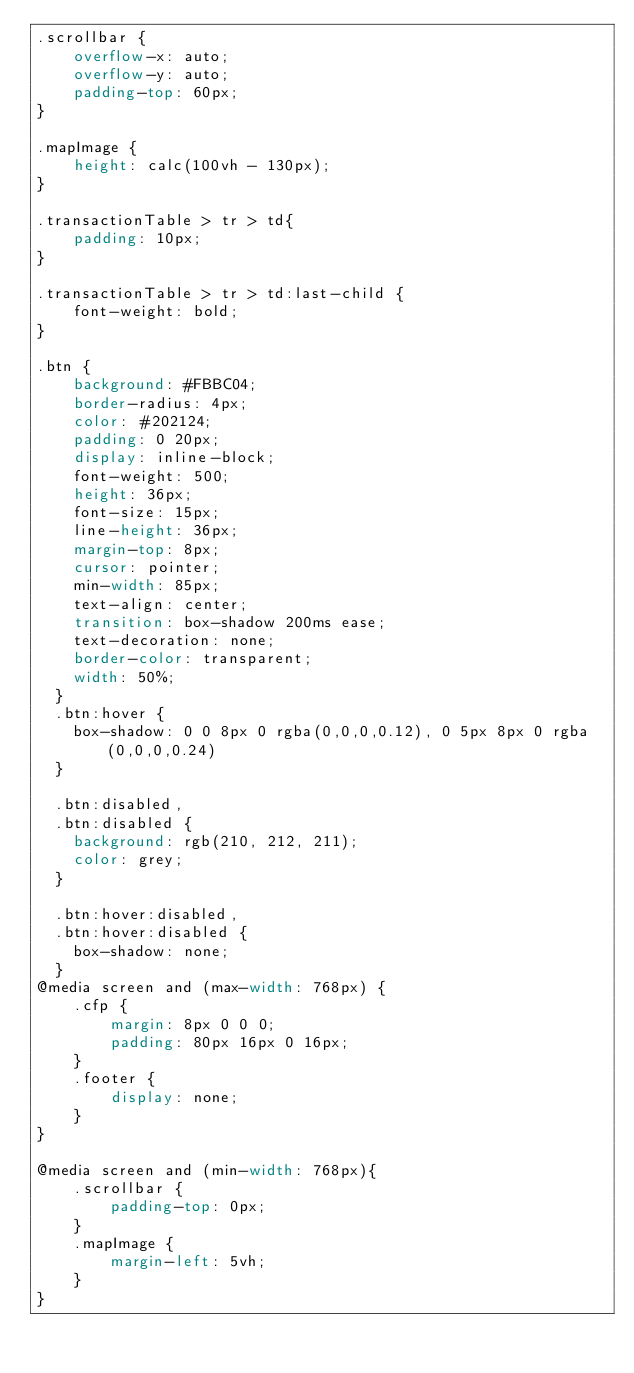<code> <loc_0><loc_0><loc_500><loc_500><_CSS_>.scrollbar {
    overflow-x: auto;
    overflow-y: auto;
    padding-top: 60px;
}

.mapImage {
    height: calc(100vh - 130px);
}

.transactionTable > tr > td{
    padding: 10px;
}

.transactionTable > tr > td:last-child {
    font-weight: bold;
}

.btn {
    background: #FBBC04;
    border-radius: 4px;
    color: #202124;
    padding: 0 20px;
    display: inline-block;
    font-weight: 500;
    height: 36px;
    font-size: 15px;
    line-height: 36px;
    margin-top: 8px;
    cursor: pointer;
    min-width: 85px;
    text-align: center;
    transition: box-shadow 200ms ease;
    text-decoration: none;
    border-color: transparent;
    width: 50%;
  }
  .btn:hover {
    box-shadow: 0 0 8px 0 rgba(0,0,0,0.12), 0 5px 8px 0 rgba(0,0,0,0.24)
  }
  
  .btn:disabled,
  .btn:disabled {
    background: rgb(210, 212, 211);
    color: grey;
  } 
  
  .btn:hover:disabled,
  .btn:hover:disabled {
    box-shadow: none;
  }
@media screen and (max-width: 768px) {
    .cfp {
        margin: 8px 0 0 0;
        padding: 80px 16px 0 16px;
    }
    .footer {
        display: none;
    }
}

@media screen and (min-width: 768px){
    .scrollbar {
        padding-top: 0px;
    }
    .mapImage {
        margin-left: 5vh;
    }
}
</code> 